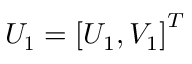Convert formula to latex. <formula><loc_0><loc_0><loc_500><loc_500>U _ { 1 } = \left [ U _ { 1 } , V _ { 1 } \right ] ^ { T }</formula> 